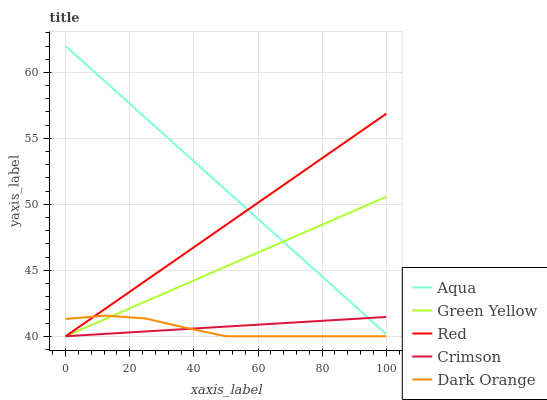Does Green Yellow have the minimum area under the curve?
Answer yes or no. No. Does Green Yellow have the maximum area under the curve?
Answer yes or no. No. Is Green Yellow the smoothest?
Answer yes or no. No. Is Green Yellow the roughest?
Answer yes or no. No. Does Aqua have the lowest value?
Answer yes or no. No. Does Dark Orange have the highest value?
Answer yes or no. No. Is Dark Orange less than Aqua?
Answer yes or no. Yes. Is Aqua greater than Dark Orange?
Answer yes or no. Yes. Does Dark Orange intersect Aqua?
Answer yes or no. No. 